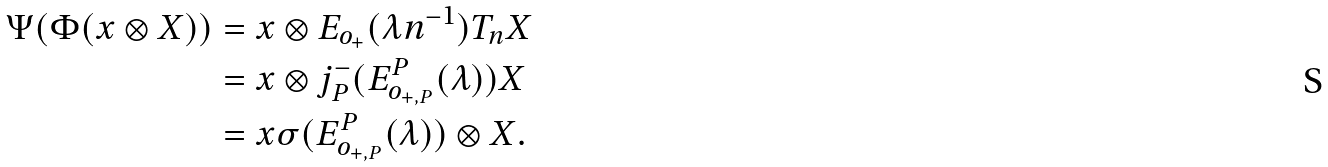<formula> <loc_0><loc_0><loc_500><loc_500>\Psi ( \Phi ( x \otimes X ) ) & = x \otimes E _ { o _ { + } } ( \lambda n ^ { - 1 } ) T _ { n } X \\ & = x \otimes j _ { P } ^ { - } ( E ^ { P } _ { o _ { + , P } } ( \lambda ) ) X \\ & = x \sigma ( E _ { o _ { + , P } } ^ { P } ( \lambda ) ) \otimes X .</formula> 